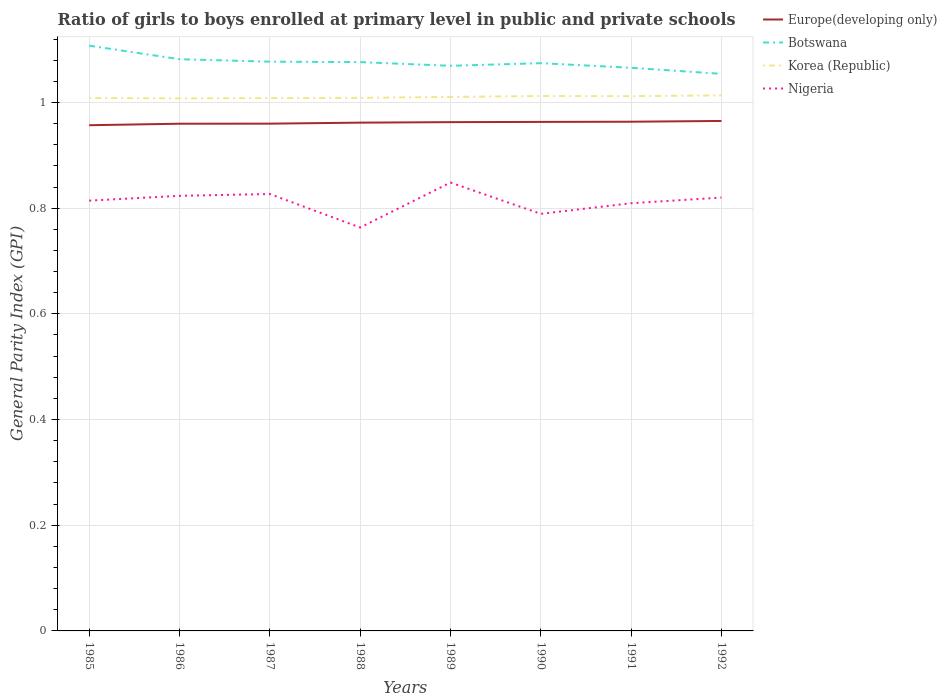How many different coloured lines are there?
Your answer should be very brief. 4. Is the number of lines equal to the number of legend labels?
Give a very brief answer. Yes. Across all years, what is the maximum general parity index in Korea (Republic)?
Ensure brevity in your answer.  1.01. What is the total general parity index in Europe(developing only) in the graph?
Offer a very short reply. -0. What is the difference between the highest and the second highest general parity index in Korea (Republic)?
Make the answer very short. 0.01. What is the difference between the highest and the lowest general parity index in Nigeria?
Give a very brief answer. 5. How many lines are there?
Make the answer very short. 4. Does the graph contain any zero values?
Your answer should be very brief. No. Does the graph contain grids?
Give a very brief answer. Yes. How are the legend labels stacked?
Ensure brevity in your answer.  Vertical. What is the title of the graph?
Your answer should be compact. Ratio of girls to boys enrolled at primary level in public and private schools. What is the label or title of the Y-axis?
Your answer should be very brief. General Parity Index (GPI). What is the General Parity Index (GPI) of Europe(developing only) in 1985?
Your response must be concise. 0.96. What is the General Parity Index (GPI) in Botswana in 1985?
Ensure brevity in your answer.  1.11. What is the General Parity Index (GPI) in Korea (Republic) in 1985?
Your answer should be very brief. 1.01. What is the General Parity Index (GPI) of Nigeria in 1985?
Give a very brief answer. 0.81. What is the General Parity Index (GPI) in Europe(developing only) in 1986?
Offer a terse response. 0.96. What is the General Parity Index (GPI) of Botswana in 1986?
Provide a succinct answer. 1.08. What is the General Parity Index (GPI) of Korea (Republic) in 1986?
Offer a very short reply. 1.01. What is the General Parity Index (GPI) in Nigeria in 1986?
Ensure brevity in your answer.  0.82. What is the General Parity Index (GPI) of Europe(developing only) in 1987?
Provide a short and direct response. 0.96. What is the General Parity Index (GPI) of Botswana in 1987?
Your response must be concise. 1.08. What is the General Parity Index (GPI) of Korea (Republic) in 1987?
Make the answer very short. 1.01. What is the General Parity Index (GPI) in Nigeria in 1987?
Make the answer very short. 0.83. What is the General Parity Index (GPI) in Europe(developing only) in 1988?
Your response must be concise. 0.96. What is the General Parity Index (GPI) in Botswana in 1988?
Provide a short and direct response. 1.08. What is the General Parity Index (GPI) of Korea (Republic) in 1988?
Offer a terse response. 1.01. What is the General Parity Index (GPI) in Nigeria in 1988?
Your answer should be compact. 0.76. What is the General Parity Index (GPI) in Europe(developing only) in 1989?
Offer a terse response. 0.96. What is the General Parity Index (GPI) in Botswana in 1989?
Your answer should be compact. 1.07. What is the General Parity Index (GPI) of Korea (Republic) in 1989?
Provide a succinct answer. 1.01. What is the General Parity Index (GPI) of Nigeria in 1989?
Offer a very short reply. 0.85. What is the General Parity Index (GPI) in Europe(developing only) in 1990?
Provide a short and direct response. 0.96. What is the General Parity Index (GPI) of Botswana in 1990?
Offer a terse response. 1.07. What is the General Parity Index (GPI) of Korea (Republic) in 1990?
Offer a terse response. 1.01. What is the General Parity Index (GPI) in Nigeria in 1990?
Your answer should be very brief. 0.79. What is the General Parity Index (GPI) of Europe(developing only) in 1991?
Your answer should be compact. 0.96. What is the General Parity Index (GPI) of Botswana in 1991?
Your answer should be compact. 1.07. What is the General Parity Index (GPI) of Korea (Republic) in 1991?
Your answer should be very brief. 1.01. What is the General Parity Index (GPI) in Nigeria in 1991?
Keep it short and to the point. 0.81. What is the General Parity Index (GPI) of Europe(developing only) in 1992?
Offer a terse response. 0.97. What is the General Parity Index (GPI) in Botswana in 1992?
Give a very brief answer. 1.05. What is the General Parity Index (GPI) in Korea (Republic) in 1992?
Offer a terse response. 1.01. What is the General Parity Index (GPI) of Nigeria in 1992?
Keep it short and to the point. 0.82. Across all years, what is the maximum General Parity Index (GPI) in Europe(developing only)?
Offer a terse response. 0.97. Across all years, what is the maximum General Parity Index (GPI) in Botswana?
Your answer should be very brief. 1.11. Across all years, what is the maximum General Parity Index (GPI) of Korea (Republic)?
Your answer should be compact. 1.01. Across all years, what is the maximum General Parity Index (GPI) in Nigeria?
Provide a succinct answer. 0.85. Across all years, what is the minimum General Parity Index (GPI) in Europe(developing only)?
Ensure brevity in your answer.  0.96. Across all years, what is the minimum General Parity Index (GPI) in Botswana?
Ensure brevity in your answer.  1.05. Across all years, what is the minimum General Parity Index (GPI) in Korea (Republic)?
Your answer should be very brief. 1.01. Across all years, what is the minimum General Parity Index (GPI) in Nigeria?
Provide a succinct answer. 0.76. What is the total General Parity Index (GPI) of Europe(developing only) in the graph?
Provide a short and direct response. 7.69. What is the total General Parity Index (GPI) in Botswana in the graph?
Your answer should be very brief. 8.61. What is the total General Parity Index (GPI) in Korea (Republic) in the graph?
Your answer should be compact. 8.08. What is the total General Parity Index (GPI) of Nigeria in the graph?
Provide a short and direct response. 6.49. What is the difference between the General Parity Index (GPI) of Europe(developing only) in 1985 and that in 1986?
Keep it short and to the point. -0. What is the difference between the General Parity Index (GPI) in Botswana in 1985 and that in 1986?
Your answer should be very brief. 0.03. What is the difference between the General Parity Index (GPI) of Korea (Republic) in 1985 and that in 1986?
Ensure brevity in your answer.  0. What is the difference between the General Parity Index (GPI) of Nigeria in 1985 and that in 1986?
Your answer should be very brief. -0.01. What is the difference between the General Parity Index (GPI) in Europe(developing only) in 1985 and that in 1987?
Make the answer very short. -0. What is the difference between the General Parity Index (GPI) in Botswana in 1985 and that in 1987?
Provide a short and direct response. 0.03. What is the difference between the General Parity Index (GPI) of Nigeria in 1985 and that in 1987?
Ensure brevity in your answer.  -0.01. What is the difference between the General Parity Index (GPI) of Europe(developing only) in 1985 and that in 1988?
Offer a terse response. -0. What is the difference between the General Parity Index (GPI) of Botswana in 1985 and that in 1988?
Ensure brevity in your answer.  0.03. What is the difference between the General Parity Index (GPI) in Korea (Republic) in 1985 and that in 1988?
Your answer should be very brief. -0. What is the difference between the General Parity Index (GPI) in Nigeria in 1985 and that in 1988?
Your answer should be very brief. 0.05. What is the difference between the General Parity Index (GPI) of Europe(developing only) in 1985 and that in 1989?
Your answer should be very brief. -0.01. What is the difference between the General Parity Index (GPI) in Botswana in 1985 and that in 1989?
Your answer should be compact. 0.04. What is the difference between the General Parity Index (GPI) in Korea (Republic) in 1985 and that in 1989?
Offer a very short reply. -0. What is the difference between the General Parity Index (GPI) of Nigeria in 1985 and that in 1989?
Give a very brief answer. -0.03. What is the difference between the General Parity Index (GPI) in Europe(developing only) in 1985 and that in 1990?
Keep it short and to the point. -0.01. What is the difference between the General Parity Index (GPI) of Botswana in 1985 and that in 1990?
Make the answer very short. 0.03. What is the difference between the General Parity Index (GPI) in Korea (Republic) in 1985 and that in 1990?
Offer a terse response. -0. What is the difference between the General Parity Index (GPI) of Nigeria in 1985 and that in 1990?
Ensure brevity in your answer.  0.03. What is the difference between the General Parity Index (GPI) of Europe(developing only) in 1985 and that in 1991?
Your response must be concise. -0.01. What is the difference between the General Parity Index (GPI) in Botswana in 1985 and that in 1991?
Keep it short and to the point. 0.04. What is the difference between the General Parity Index (GPI) in Korea (Republic) in 1985 and that in 1991?
Provide a succinct answer. -0. What is the difference between the General Parity Index (GPI) of Nigeria in 1985 and that in 1991?
Give a very brief answer. 0. What is the difference between the General Parity Index (GPI) in Europe(developing only) in 1985 and that in 1992?
Provide a succinct answer. -0.01. What is the difference between the General Parity Index (GPI) of Botswana in 1985 and that in 1992?
Offer a terse response. 0.05. What is the difference between the General Parity Index (GPI) of Korea (Republic) in 1985 and that in 1992?
Ensure brevity in your answer.  -0. What is the difference between the General Parity Index (GPI) of Nigeria in 1985 and that in 1992?
Offer a terse response. -0.01. What is the difference between the General Parity Index (GPI) in Europe(developing only) in 1986 and that in 1987?
Your answer should be compact. -0. What is the difference between the General Parity Index (GPI) of Botswana in 1986 and that in 1987?
Your answer should be compact. 0. What is the difference between the General Parity Index (GPI) in Korea (Republic) in 1986 and that in 1987?
Keep it short and to the point. -0. What is the difference between the General Parity Index (GPI) of Nigeria in 1986 and that in 1987?
Offer a terse response. -0. What is the difference between the General Parity Index (GPI) of Europe(developing only) in 1986 and that in 1988?
Provide a succinct answer. -0. What is the difference between the General Parity Index (GPI) of Botswana in 1986 and that in 1988?
Give a very brief answer. 0.01. What is the difference between the General Parity Index (GPI) in Korea (Republic) in 1986 and that in 1988?
Provide a short and direct response. -0. What is the difference between the General Parity Index (GPI) in Nigeria in 1986 and that in 1988?
Your answer should be very brief. 0.06. What is the difference between the General Parity Index (GPI) in Europe(developing only) in 1986 and that in 1989?
Provide a succinct answer. -0. What is the difference between the General Parity Index (GPI) of Botswana in 1986 and that in 1989?
Provide a short and direct response. 0.01. What is the difference between the General Parity Index (GPI) of Korea (Republic) in 1986 and that in 1989?
Offer a terse response. -0. What is the difference between the General Parity Index (GPI) of Nigeria in 1986 and that in 1989?
Your answer should be very brief. -0.03. What is the difference between the General Parity Index (GPI) of Europe(developing only) in 1986 and that in 1990?
Offer a terse response. -0. What is the difference between the General Parity Index (GPI) in Botswana in 1986 and that in 1990?
Your answer should be compact. 0.01. What is the difference between the General Parity Index (GPI) in Korea (Republic) in 1986 and that in 1990?
Offer a very short reply. -0. What is the difference between the General Parity Index (GPI) in Nigeria in 1986 and that in 1990?
Ensure brevity in your answer.  0.03. What is the difference between the General Parity Index (GPI) in Europe(developing only) in 1986 and that in 1991?
Offer a very short reply. -0. What is the difference between the General Parity Index (GPI) in Botswana in 1986 and that in 1991?
Keep it short and to the point. 0.02. What is the difference between the General Parity Index (GPI) in Korea (Republic) in 1986 and that in 1991?
Give a very brief answer. -0. What is the difference between the General Parity Index (GPI) in Nigeria in 1986 and that in 1991?
Keep it short and to the point. 0.01. What is the difference between the General Parity Index (GPI) in Europe(developing only) in 1986 and that in 1992?
Provide a succinct answer. -0.01. What is the difference between the General Parity Index (GPI) of Botswana in 1986 and that in 1992?
Provide a succinct answer. 0.03. What is the difference between the General Parity Index (GPI) in Korea (Republic) in 1986 and that in 1992?
Keep it short and to the point. -0.01. What is the difference between the General Parity Index (GPI) of Nigeria in 1986 and that in 1992?
Ensure brevity in your answer.  0. What is the difference between the General Parity Index (GPI) in Europe(developing only) in 1987 and that in 1988?
Your answer should be compact. -0. What is the difference between the General Parity Index (GPI) of Botswana in 1987 and that in 1988?
Give a very brief answer. 0. What is the difference between the General Parity Index (GPI) in Korea (Republic) in 1987 and that in 1988?
Offer a terse response. -0. What is the difference between the General Parity Index (GPI) in Nigeria in 1987 and that in 1988?
Provide a succinct answer. 0.06. What is the difference between the General Parity Index (GPI) of Europe(developing only) in 1987 and that in 1989?
Your response must be concise. -0. What is the difference between the General Parity Index (GPI) in Botswana in 1987 and that in 1989?
Offer a very short reply. 0.01. What is the difference between the General Parity Index (GPI) in Korea (Republic) in 1987 and that in 1989?
Give a very brief answer. -0. What is the difference between the General Parity Index (GPI) of Nigeria in 1987 and that in 1989?
Your response must be concise. -0.02. What is the difference between the General Parity Index (GPI) of Europe(developing only) in 1987 and that in 1990?
Provide a short and direct response. -0. What is the difference between the General Parity Index (GPI) in Botswana in 1987 and that in 1990?
Provide a succinct answer. 0. What is the difference between the General Parity Index (GPI) of Korea (Republic) in 1987 and that in 1990?
Ensure brevity in your answer.  -0. What is the difference between the General Parity Index (GPI) of Nigeria in 1987 and that in 1990?
Your answer should be very brief. 0.04. What is the difference between the General Parity Index (GPI) in Europe(developing only) in 1987 and that in 1991?
Provide a succinct answer. -0. What is the difference between the General Parity Index (GPI) in Botswana in 1987 and that in 1991?
Keep it short and to the point. 0.01. What is the difference between the General Parity Index (GPI) of Korea (Republic) in 1987 and that in 1991?
Give a very brief answer. -0. What is the difference between the General Parity Index (GPI) in Nigeria in 1987 and that in 1991?
Offer a very short reply. 0.02. What is the difference between the General Parity Index (GPI) of Europe(developing only) in 1987 and that in 1992?
Keep it short and to the point. -0.01. What is the difference between the General Parity Index (GPI) of Botswana in 1987 and that in 1992?
Your answer should be compact. 0.02. What is the difference between the General Parity Index (GPI) of Korea (Republic) in 1987 and that in 1992?
Offer a terse response. -0.01. What is the difference between the General Parity Index (GPI) in Nigeria in 1987 and that in 1992?
Make the answer very short. 0.01. What is the difference between the General Parity Index (GPI) in Europe(developing only) in 1988 and that in 1989?
Make the answer very short. -0. What is the difference between the General Parity Index (GPI) of Botswana in 1988 and that in 1989?
Your response must be concise. 0.01. What is the difference between the General Parity Index (GPI) in Korea (Republic) in 1988 and that in 1989?
Provide a short and direct response. -0. What is the difference between the General Parity Index (GPI) in Nigeria in 1988 and that in 1989?
Make the answer very short. -0.09. What is the difference between the General Parity Index (GPI) of Europe(developing only) in 1988 and that in 1990?
Ensure brevity in your answer.  -0. What is the difference between the General Parity Index (GPI) of Botswana in 1988 and that in 1990?
Make the answer very short. 0. What is the difference between the General Parity Index (GPI) in Korea (Republic) in 1988 and that in 1990?
Offer a very short reply. -0. What is the difference between the General Parity Index (GPI) in Nigeria in 1988 and that in 1990?
Your answer should be very brief. -0.03. What is the difference between the General Parity Index (GPI) of Europe(developing only) in 1988 and that in 1991?
Your response must be concise. -0. What is the difference between the General Parity Index (GPI) in Botswana in 1988 and that in 1991?
Give a very brief answer. 0.01. What is the difference between the General Parity Index (GPI) of Korea (Republic) in 1988 and that in 1991?
Provide a succinct answer. -0. What is the difference between the General Parity Index (GPI) of Nigeria in 1988 and that in 1991?
Offer a terse response. -0.05. What is the difference between the General Parity Index (GPI) in Europe(developing only) in 1988 and that in 1992?
Your response must be concise. -0. What is the difference between the General Parity Index (GPI) in Botswana in 1988 and that in 1992?
Provide a succinct answer. 0.02. What is the difference between the General Parity Index (GPI) in Korea (Republic) in 1988 and that in 1992?
Offer a terse response. -0. What is the difference between the General Parity Index (GPI) of Nigeria in 1988 and that in 1992?
Give a very brief answer. -0.06. What is the difference between the General Parity Index (GPI) in Europe(developing only) in 1989 and that in 1990?
Ensure brevity in your answer.  -0. What is the difference between the General Parity Index (GPI) of Botswana in 1989 and that in 1990?
Your answer should be compact. -0.01. What is the difference between the General Parity Index (GPI) in Korea (Republic) in 1989 and that in 1990?
Your answer should be very brief. -0. What is the difference between the General Parity Index (GPI) of Nigeria in 1989 and that in 1990?
Your response must be concise. 0.06. What is the difference between the General Parity Index (GPI) in Europe(developing only) in 1989 and that in 1991?
Offer a terse response. -0. What is the difference between the General Parity Index (GPI) in Botswana in 1989 and that in 1991?
Your answer should be compact. 0. What is the difference between the General Parity Index (GPI) in Korea (Republic) in 1989 and that in 1991?
Your answer should be compact. -0. What is the difference between the General Parity Index (GPI) in Nigeria in 1989 and that in 1991?
Give a very brief answer. 0.04. What is the difference between the General Parity Index (GPI) in Europe(developing only) in 1989 and that in 1992?
Your response must be concise. -0. What is the difference between the General Parity Index (GPI) in Botswana in 1989 and that in 1992?
Offer a terse response. 0.02. What is the difference between the General Parity Index (GPI) of Korea (Republic) in 1989 and that in 1992?
Ensure brevity in your answer.  -0. What is the difference between the General Parity Index (GPI) in Nigeria in 1989 and that in 1992?
Your answer should be compact. 0.03. What is the difference between the General Parity Index (GPI) in Europe(developing only) in 1990 and that in 1991?
Offer a very short reply. -0. What is the difference between the General Parity Index (GPI) in Botswana in 1990 and that in 1991?
Ensure brevity in your answer.  0.01. What is the difference between the General Parity Index (GPI) of Korea (Republic) in 1990 and that in 1991?
Give a very brief answer. 0. What is the difference between the General Parity Index (GPI) of Nigeria in 1990 and that in 1991?
Your response must be concise. -0.02. What is the difference between the General Parity Index (GPI) of Europe(developing only) in 1990 and that in 1992?
Your response must be concise. -0. What is the difference between the General Parity Index (GPI) in Botswana in 1990 and that in 1992?
Your response must be concise. 0.02. What is the difference between the General Parity Index (GPI) of Korea (Republic) in 1990 and that in 1992?
Your answer should be very brief. -0. What is the difference between the General Parity Index (GPI) of Nigeria in 1990 and that in 1992?
Ensure brevity in your answer.  -0.03. What is the difference between the General Parity Index (GPI) of Europe(developing only) in 1991 and that in 1992?
Offer a terse response. -0. What is the difference between the General Parity Index (GPI) of Botswana in 1991 and that in 1992?
Provide a short and direct response. 0.01. What is the difference between the General Parity Index (GPI) of Korea (Republic) in 1991 and that in 1992?
Offer a very short reply. -0. What is the difference between the General Parity Index (GPI) in Nigeria in 1991 and that in 1992?
Your answer should be compact. -0.01. What is the difference between the General Parity Index (GPI) of Europe(developing only) in 1985 and the General Parity Index (GPI) of Botswana in 1986?
Make the answer very short. -0.12. What is the difference between the General Parity Index (GPI) in Europe(developing only) in 1985 and the General Parity Index (GPI) in Korea (Republic) in 1986?
Offer a very short reply. -0.05. What is the difference between the General Parity Index (GPI) of Europe(developing only) in 1985 and the General Parity Index (GPI) of Nigeria in 1986?
Your answer should be very brief. 0.13. What is the difference between the General Parity Index (GPI) of Botswana in 1985 and the General Parity Index (GPI) of Korea (Republic) in 1986?
Ensure brevity in your answer.  0.1. What is the difference between the General Parity Index (GPI) of Botswana in 1985 and the General Parity Index (GPI) of Nigeria in 1986?
Make the answer very short. 0.28. What is the difference between the General Parity Index (GPI) in Korea (Republic) in 1985 and the General Parity Index (GPI) in Nigeria in 1986?
Provide a succinct answer. 0.19. What is the difference between the General Parity Index (GPI) of Europe(developing only) in 1985 and the General Parity Index (GPI) of Botswana in 1987?
Your answer should be compact. -0.12. What is the difference between the General Parity Index (GPI) of Europe(developing only) in 1985 and the General Parity Index (GPI) of Korea (Republic) in 1987?
Give a very brief answer. -0.05. What is the difference between the General Parity Index (GPI) of Europe(developing only) in 1985 and the General Parity Index (GPI) of Nigeria in 1987?
Offer a terse response. 0.13. What is the difference between the General Parity Index (GPI) in Botswana in 1985 and the General Parity Index (GPI) in Korea (Republic) in 1987?
Keep it short and to the point. 0.1. What is the difference between the General Parity Index (GPI) in Botswana in 1985 and the General Parity Index (GPI) in Nigeria in 1987?
Your answer should be very brief. 0.28. What is the difference between the General Parity Index (GPI) of Korea (Republic) in 1985 and the General Parity Index (GPI) of Nigeria in 1987?
Offer a terse response. 0.18. What is the difference between the General Parity Index (GPI) of Europe(developing only) in 1985 and the General Parity Index (GPI) of Botswana in 1988?
Your answer should be very brief. -0.12. What is the difference between the General Parity Index (GPI) of Europe(developing only) in 1985 and the General Parity Index (GPI) of Korea (Republic) in 1988?
Offer a terse response. -0.05. What is the difference between the General Parity Index (GPI) in Europe(developing only) in 1985 and the General Parity Index (GPI) in Nigeria in 1988?
Offer a terse response. 0.19. What is the difference between the General Parity Index (GPI) of Botswana in 1985 and the General Parity Index (GPI) of Korea (Republic) in 1988?
Your response must be concise. 0.1. What is the difference between the General Parity Index (GPI) of Botswana in 1985 and the General Parity Index (GPI) of Nigeria in 1988?
Ensure brevity in your answer.  0.34. What is the difference between the General Parity Index (GPI) in Korea (Republic) in 1985 and the General Parity Index (GPI) in Nigeria in 1988?
Make the answer very short. 0.25. What is the difference between the General Parity Index (GPI) of Europe(developing only) in 1985 and the General Parity Index (GPI) of Botswana in 1989?
Offer a very short reply. -0.11. What is the difference between the General Parity Index (GPI) in Europe(developing only) in 1985 and the General Parity Index (GPI) in Korea (Republic) in 1989?
Offer a terse response. -0.05. What is the difference between the General Parity Index (GPI) of Europe(developing only) in 1985 and the General Parity Index (GPI) of Nigeria in 1989?
Ensure brevity in your answer.  0.11. What is the difference between the General Parity Index (GPI) of Botswana in 1985 and the General Parity Index (GPI) of Korea (Republic) in 1989?
Your response must be concise. 0.1. What is the difference between the General Parity Index (GPI) of Botswana in 1985 and the General Parity Index (GPI) of Nigeria in 1989?
Your answer should be very brief. 0.26. What is the difference between the General Parity Index (GPI) in Korea (Republic) in 1985 and the General Parity Index (GPI) in Nigeria in 1989?
Ensure brevity in your answer.  0.16. What is the difference between the General Parity Index (GPI) of Europe(developing only) in 1985 and the General Parity Index (GPI) of Botswana in 1990?
Make the answer very short. -0.12. What is the difference between the General Parity Index (GPI) of Europe(developing only) in 1985 and the General Parity Index (GPI) of Korea (Republic) in 1990?
Provide a succinct answer. -0.06. What is the difference between the General Parity Index (GPI) in Europe(developing only) in 1985 and the General Parity Index (GPI) in Nigeria in 1990?
Provide a succinct answer. 0.17. What is the difference between the General Parity Index (GPI) of Botswana in 1985 and the General Parity Index (GPI) of Korea (Republic) in 1990?
Make the answer very short. 0.1. What is the difference between the General Parity Index (GPI) in Botswana in 1985 and the General Parity Index (GPI) in Nigeria in 1990?
Ensure brevity in your answer.  0.32. What is the difference between the General Parity Index (GPI) in Korea (Republic) in 1985 and the General Parity Index (GPI) in Nigeria in 1990?
Your response must be concise. 0.22. What is the difference between the General Parity Index (GPI) in Europe(developing only) in 1985 and the General Parity Index (GPI) in Botswana in 1991?
Provide a succinct answer. -0.11. What is the difference between the General Parity Index (GPI) of Europe(developing only) in 1985 and the General Parity Index (GPI) of Korea (Republic) in 1991?
Keep it short and to the point. -0.06. What is the difference between the General Parity Index (GPI) of Europe(developing only) in 1985 and the General Parity Index (GPI) of Nigeria in 1991?
Keep it short and to the point. 0.15. What is the difference between the General Parity Index (GPI) of Botswana in 1985 and the General Parity Index (GPI) of Korea (Republic) in 1991?
Your response must be concise. 0.1. What is the difference between the General Parity Index (GPI) in Botswana in 1985 and the General Parity Index (GPI) in Nigeria in 1991?
Keep it short and to the point. 0.3. What is the difference between the General Parity Index (GPI) in Korea (Republic) in 1985 and the General Parity Index (GPI) in Nigeria in 1991?
Your response must be concise. 0.2. What is the difference between the General Parity Index (GPI) in Europe(developing only) in 1985 and the General Parity Index (GPI) in Botswana in 1992?
Make the answer very short. -0.1. What is the difference between the General Parity Index (GPI) of Europe(developing only) in 1985 and the General Parity Index (GPI) of Korea (Republic) in 1992?
Ensure brevity in your answer.  -0.06. What is the difference between the General Parity Index (GPI) of Europe(developing only) in 1985 and the General Parity Index (GPI) of Nigeria in 1992?
Your response must be concise. 0.14. What is the difference between the General Parity Index (GPI) of Botswana in 1985 and the General Parity Index (GPI) of Korea (Republic) in 1992?
Offer a very short reply. 0.09. What is the difference between the General Parity Index (GPI) of Botswana in 1985 and the General Parity Index (GPI) of Nigeria in 1992?
Keep it short and to the point. 0.29. What is the difference between the General Parity Index (GPI) of Korea (Republic) in 1985 and the General Parity Index (GPI) of Nigeria in 1992?
Make the answer very short. 0.19. What is the difference between the General Parity Index (GPI) of Europe(developing only) in 1986 and the General Parity Index (GPI) of Botswana in 1987?
Provide a succinct answer. -0.12. What is the difference between the General Parity Index (GPI) in Europe(developing only) in 1986 and the General Parity Index (GPI) in Korea (Republic) in 1987?
Make the answer very short. -0.05. What is the difference between the General Parity Index (GPI) of Europe(developing only) in 1986 and the General Parity Index (GPI) of Nigeria in 1987?
Provide a short and direct response. 0.13. What is the difference between the General Parity Index (GPI) of Botswana in 1986 and the General Parity Index (GPI) of Korea (Republic) in 1987?
Provide a short and direct response. 0.07. What is the difference between the General Parity Index (GPI) of Botswana in 1986 and the General Parity Index (GPI) of Nigeria in 1987?
Your response must be concise. 0.26. What is the difference between the General Parity Index (GPI) of Korea (Republic) in 1986 and the General Parity Index (GPI) of Nigeria in 1987?
Provide a succinct answer. 0.18. What is the difference between the General Parity Index (GPI) of Europe(developing only) in 1986 and the General Parity Index (GPI) of Botswana in 1988?
Ensure brevity in your answer.  -0.12. What is the difference between the General Parity Index (GPI) of Europe(developing only) in 1986 and the General Parity Index (GPI) of Korea (Republic) in 1988?
Make the answer very short. -0.05. What is the difference between the General Parity Index (GPI) of Europe(developing only) in 1986 and the General Parity Index (GPI) of Nigeria in 1988?
Ensure brevity in your answer.  0.2. What is the difference between the General Parity Index (GPI) in Botswana in 1986 and the General Parity Index (GPI) in Korea (Republic) in 1988?
Offer a very short reply. 0.07. What is the difference between the General Parity Index (GPI) in Botswana in 1986 and the General Parity Index (GPI) in Nigeria in 1988?
Provide a short and direct response. 0.32. What is the difference between the General Parity Index (GPI) of Korea (Republic) in 1986 and the General Parity Index (GPI) of Nigeria in 1988?
Keep it short and to the point. 0.24. What is the difference between the General Parity Index (GPI) of Europe(developing only) in 1986 and the General Parity Index (GPI) of Botswana in 1989?
Your response must be concise. -0.11. What is the difference between the General Parity Index (GPI) in Europe(developing only) in 1986 and the General Parity Index (GPI) in Korea (Republic) in 1989?
Offer a terse response. -0.05. What is the difference between the General Parity Index (GPI) of Europe(developing only) in 1986 and the General Parity Index (GPI) of Nigeria in 1989?
Offer a very short reply. 0.11. What is the difference between the General Parity Index (GPI) in Botswana in 1986 and the General Parity Index (GPI) in Korea (Republic) in 1989?
Provide a succinct answer. 0.07. What is the difference between the General Parity Index (GPI) in Botswana in 1986 and the General Parity Index (GPI) in Nigeria in 1989?
Provide a short and direct response. 0.23. What is the difference between the General Parity Index (GPI) of Korea (Republic) in 1986 and the General Parity Index (GPI) of Nigeria in 1989?
Ensure brevity in your answer.  0.16. What is the difference between the General Parity Index (GPI) of Europe(developing only) in 1986 and the General Parity Index (GPI) of Botswana in 1990?
Your response must be concise. -0.11. What is the difference between the General Parity Index (GPI) of Europe(developing only) in 1986 and the General Parity Index (GPI) of Korea (Republic) in 1990?
Ensure brevity in your answer.  -0.05. What is the difference between the General Parity Index (GPI) in Europe(developing only) in 1986 and the General Parity Index (GPI) in Nigeria in 1990?
Provide a succinct answer. 0.17. What is the difference between the General Parity Index (GPI) in Botswana in 1986 and the General Parity Index (GPI) in Korea (Republic) in 1990?
Your answer should be compact. 0.07. What is the difference between the General Parity Index (GPI) of Botswana in 1986 and the General Parity Index (GPI) of Nigeria in 1990?
Your answer should be very brief. 0.29. What is the difference between the General Parity Index (GPI) in Korea (Republic) in 1986 and the General Parity Index (GPI) in Nigeria in 1990?
Your answer should be very brief. 0.22. What is the difference between the General Parity Index (GPI) of Europe(developing only) in 1986 and the General Parity Index (GPI) of Botswana in 1991?
Ensure brevity in your answer.  -0.11. What is the difference between the General Parity Index (GPI) in Europe(developing only) in 1986 and the General Parity Index (GPI) in Korea (Republic) in 1991?
Make the answer very short. -0.05. What is the difference between the General Parity Index (GPI) of Europe(developing only) in 1986 and the General Parity Index (GPI) of Nigeria in 1991?
Give a very brief answer. 0.15. What is the difference between the General Parity Index (GPI) of Botswana in 1986 and the General Parity Index (GPI) of Korea (Republic) in 1991?
Offer a very short reply. 0.07. What is the difference between the General Parity Index (GPI) in Botswana in 1986 and the General Parity Index (GPI) in Nigeria in 1991?
Keep it short and to the point. 0.27. What is the difference between the General Parity Index (GPI) in Korea (Republic) in 1986 and the General Parity Index (GPI) in Nigeria in 1991?
Your response must be concise. 0.2. What is the difference between the General Parity Index (GPI) of Europe(developing only) in 1986 and the General Parity Index (GPI) of Botswana in 1992?
Offer a terse response. -0.09. What is the difference between the General Parity Index (GPI) of Europe(developing only) in 1986 and the General Parity Index (GPI) of Korea (Republic) in 1992?
Offer a very short reply. -0.05. What is the difference between the General Parity Index (GPI) of Europe(developing only) in 1986 and the General Parity Index (GPI) of Nigeria in 1992?
Provide a succinct answer. 0.14. What is the difference between the General Parity Index (GPI) of Botswana in 1986 and the General Parity Index (GPI) of Korea (Republic) in 1992?
Give a very brief answer. 0.07. What is the difference between the General Parity Index (GPI) of Botswana in 1986 and the General Parity Index (GPI) of Nigeria in 1992?
Offer a very short reply. 0.26. What is the difference between the General Parity Index (GPI) in Korea (Republic) in 1986 and the General Parity Index (GPI) in Nigeria in 1992?
Your answer should be very brief. 0.19. What is the difference between the General Parity Index (GPI) of Europe(developing only) in 1987 and the General Parity Index (GPI) of Botswana in 1988?
Your answer should be compact. -0.12. What is the difference between the General Parity Index (GPI) in Europe(developing only) in 1987 and the General Parity Index (GPI) in Korea (Republic) in 1988?
Your response must be concise. -0.05. What is the difference between the General Parity Index (GPI) in Europe(developing only) in 1987 and the General Parity Index (GPI) in Nigeria in 1988?
Offer a very short reply. 0.2. What is the difference between the General Parity Index (GPI) of Botswana in 1987 and the General Parity Index (GPI) of Korea (Republic) in 1988?
Ensure brevity in your answer.  0.07. What is the difference between the General Parity Index (GPI) in Botswana in 1987 and the General Parity Index (GPI) in Nigeria in 1988?
Provide a short and direct response. 0.31. What is the difference between the General Parity Index (GPI) of Korea (Republic) in 1987 and the General Parity Index (GPI) of Nigeria in 1988?
Provide a succinct answer. 0.24. What is the difference between the General Parity Index (GPI) in Europe(developing only) in 1987 and the General Parity Index (GPI) in Botswana in 1989?
Provide a succinct answer. -0.11. What is the difference between the General Parity Index (GPI) in Europe(developing only) in 1987 and the General Parity Index (GPI) in Korea (Republic) in 1989?
Offer a very short reply. -0.05. What is the difference between the General Parity Index (GPI) in Europe(developing only) in 1987 and the General Parity Index (GPI) in Nigeria in 1989?
Ensure brevity in your answer.  0.11. What is the difference between the General Parity Index (GPI) in Botswana in 1987 and the General Parity Index (GPI) in Korea (Republic) in 1989?
Your answer should be compact. 0.07. What is the difference between the General Parity Index (GPI) of Botswana in 1987 and the General Parity Index (GPI) of Nigeria in 1989?
Your answer should be very brief. 0.23. What is the difference between the General Parity Index (GPI) of Korea (Republic) in 1987 and the General Parity Index (GPI) of Nigeria in 1989?
Make the answer very short. 0.16. What is the difference between the General Parity Index (GPI) in Europe(developing only) in 1987 and the General Parity Index (GPI) in Botswana in 1990?
Make the answer very short. -0.11. What is the difference between the General Parity Index (GPI) of Europe(developing only) in 1987 and the General Parity Index (GPI) of Korea (Republic) in 1990?
Give a very brief answer. -0.05. What is the difference between the General Parity Index (GPI) of Europe(developing only) in 1987 and the General Parity Index (GPI) of Nigeria in 1990?
Keep it short and to the point. 0.17. What is the difference between the General Parity Index (GPI) in Botswana in 1987 and the General Parity Index (GPI) in Korea (Republic) in 1990?
Keep it short and to the point. 0.07. What is the difference between the General Parity Index (GPI) of Botswana in 1987 and the General Parity Index (GPI) of Nigeria in 1990?
Keep it short and to the point. 0.29. What is the difference between the General Parity Index (GPI) in Korea (Republic) in 1987 and the General Parity Index (GPI) in Nigeria in 1990?
Your answer should be very brief. 0.22. What is the difference between the General Parity Index (GPI) in Europe(developing only) in 1987 and the General Parity Index (GPI) in Botswana in 1991?
Your answer should be very brief. -0.11. What is the difference between the General Parity Index (GPI) of Europe(developing only) in 1987 and the General Parity Index (GPI) of Korea (Republic) in 1991?
Ensure brevity in your answer.  -0.05. What is the difference between the General Parity Index (GPI) of Europe(developing only) in 1987 and the General Parity Index (GPI) of Nigeria in 1991?
Give a very brief answer. 0.15. What is the difference between the General Parity Index (GPI) of Botswana in 1987 and the General Parity Index (GPI) of Korea (Republic) in 1991?
Ensure brevity in your answer.  0.07. What is the difference between the General Parity Index (GPI) in Botswana in 1987 and the General Parity Index (GPI) in Nigeria in 1991?
Make the answer very short. 0.27. What is the difference between the General Parity Index (GPI) in Korea (Republic) in 1987 and the General Parity Index (GPI) in Nigeria in 1991?
Give a very brief answer. 0.2. What is the difference between the General Parity Index (GPI) of Europe(developing only) in 1987 and the General Parity Index (GPI) of Botswana in 1992?
Your answer should be compact. -0.09. What is the difference between the General Parity Index (GPI) of Europe(developing only) in 1987 and the General Parity Index (GPI) of Korea (Republic) in 1992?
Provide a succinct answer. -0.05. What is the difference between the General Parity Index (GPI) in Europe(developing only) in 1987 and the General Parity Index (GPI) in Nigeria in 1992?
Offer a very short reply. 0.14. What is the difference between the General Parity Index (GPI) in Botswana in 1987 and the General Parity Index (GPI) in Korea (Republic) in 1992?
Keep it short and to the point. 0.06. What is the difference between the General Parity Index (GPI) in Botswana in 1987 and the General Parity Index (GPI) in Nigeria in 1992?
Make the answer very short. 0.26. What is the difference between the General Parity Index (GPI) in Korea (Republic) in 1987 and the General Parity Index (GPI) in Nigeria in 1992?
Keep it short and to the point. 0.19. What is the difference between the General Parity Index (GPI) of Europe(developing only) in 1988 and the General Parity Index (GPI) of Botswana in 1989?
Offer a very short reply. -0.11. What is the difference between the General Parity Index (GPI) of Europe(developing only) in 1988 and the General Parity Index (GPI) of Korea (Republic) in 1989?
Offer a terse response. -0.05. What is the difference between the General Parity Index (GPI) of Europe(developing only) in 1988 and the General Parity Index (GPI) of Nigeria in 1989?
Your answer should be compact. 0.11. What is the difference between the General Parity Index (GPI) of Botswana in 1988 and the General Parity Index (GPI) of Korea (Republic) in 1989?
Your response must be concise. 0.07. What is the difference between the General Parity Index (GPI) of Botswana in 1988 and the General Parity Index (GPI) of Nigeria in 1989?
Ensure brevity in your answer.  0.23. What is the difference between the General Parity Index (GPI) of Korea (Republic) in 1988 and the General Parity Index (GPI) of Nigeria in 1989?
Give a very brief answer. 0.16. What is the difference between the General Parity Index (GPI) of Europe(developing only) in 1988 and the General Parity Index (GPI) of Botswana in 1990?
Ensure brevity in your answer.  -0.11. What is the difference between the General Parity Index (GPI) in Europe(developing only) in 1988 and the General Parity Index (GPI) in Korea (Republic) in 1990?
Your response must be concise. -0.05. What is the difference between the General Parity Index (GPI) in Europe(developing only) in 1988 and the General Parity Index (GPI) in Nigeria in 1990?
Give a very brief answer. 0.17. What is the difference between the General Parity Index (GPI) in Botswana in 1988 and the General Parity Index (GPI) in Korea (Republic) in 1990?
Your response must be concise. 0.06. What is the difference between the General Parity Index (GPI) of Botswana in 1988 and the General Parity Index (GPI) of Nigeria in 1990?
Make the answer very short. 0.29. What is the difference between the General Parity Index (GPI) in Korea (Republic) in 1988 and the General Parity Index (GPI) in Nigeria in 1990?
Provide a short and direct response. 0.22. What is the difference between the General Parity Index (GPI) in Europe(developing only) in 1988 and the General Parity Index (GPI) in Botswana in 1991?
Offer a very short reply. -0.1. What is the difference between the General Parity Index (GPI) in Europe(developing only) in 1988 and the General Parity Index (GPI) in Korea (Republic) in 1991?
Your response must be concise. -0.05. What is the difference between the General Parity Index (GPI) in Europe(developing only) in 1988 and the General Parity Index (GPI) in Nigeria in 1991?
Give a very brief answer. 0.15. What is the difference between the General Parity Index (GPI) of Botswana in 1988 and the General Parity Index (GPI) of Korea (Republic) in 1991?
Provide a succinct answer. 0.06. What is the difference between the General Parity Index (GPI) of Botswana in 1988 and the General Parity Index (GPI) of Nigeria in 1991?
Make the answer very short. 0.27. What is the difference between the General Parity Index (GPI) of Korea (Republic) in 1988 and the General Parity Index (GPI) of Nigeria in 1991?
Offer a very short reply. 0.2. What is the difference between the General Parity Index (GPI) of Europe(developing only) in 1988 and the General Parity Index (GPI) of Botswana in 1992?
Make the answer very short. -0.09. What is the difference between the General Parity Index (GPI) in Europe(developing only) in 1988 and the General Parity Index (GPI) in Korea (Republic) in 1992?
Provide a succinct answer. -0.05. What is the difference between the General Parity Index (GPI) in Europe(developing only) in 1988 and the General Parity Index (GPI) in Nigeria in 1992?
Give a very brief answer. 0.14. What is the difference between the General Parity Index (GPI) in Botswana in 1988 and the General Parity Index (GPI) in Korea (Republic) in 1992?
Make the answer very short. 0.06. What is the difference between the General Parity Index (GPI) in Botswana in 1988 and the General Parity Index (GPI) in Nigeria in 1992?
Offer a very short reply. 0.26. What is the difference between the General Parity Index (GPI) of Korea (Republic) in 1988 and the General Parity Index (GPI) of Nigeria in 1992?
Your answer should be compact. 0.19. What is the difference between the General Parity Index (GPI) in Europe(developing only) in 1989 and the General Parity Index (GPI) in Botswana in 1990?
Offer a terse response. -0.11. What is the difference between the General Parity Index (GPI) in Europe(developing only) in 1989 and the General Parity Index (GPI) in Korea (Republic) in 1990?
Make the answer very short. -0.05. What is the difference between the General Parity Index (GPI) in Europe(developing only) in 1989 and the General Parity Index (GPI) in Nigeria in 1990?
Offer a terse response. 0.17. What is the difference between the General Parity Index (GPI) of Botswana in 1989 and the General Parity Index (GPI) of Korea (Republic) in 1990?
Offer a very short reply. 0.06. What is the difference between the General Parity Index (GPI) of Botswana in 1989 and the General Parity Index (GPI) of Nigeria in 1990?
Provide a succinct answer. 0.28. What is the difference between the General Parity Index (GPI) in Korea (Republic) in 1989 and the General Parity Index (GPI) in Nigeria in 1990?
Offer a very short reply. 0.22. What is the difference between the General Parity Index (GPI) in Europe(developing only) in 1989 and the General Parity Index (GPI) in Botswana in 1991?
Your response must be concise. -0.1. What is the difference between the General Parity Index (GPI) of Europe(developing only) in 1989 and the General Parity Index (GPI) of Korea (Republic) in 1991?
Your answer should be compact. -0.05. What is the difference between the General Parity Index (GPI) of Europe(developing only) in 1989 and the General Parity Index (GPI) of Nigeria in 1991?
Give a very brief answer. 0.15. What is the difference between the General Parity Index (GPI) in Botswana in 1989 and the General Parity Index (GPI) in Korea (Republic) in 1991?
Your response must be concise. 0.06. What is the difference between the General Parity Index (GPI) of Botswana in 1989 and the General Parity Index (GPI) of Nigeria in 1991?
Provide a short and direct response. 0.26. What is the difference between the General Parity Index (GPI) in Korea (Republic) in 1989 and the General Parity Index (GPI) in Nigeria in 1991?
Ensure brevity in your answer.  0.2. What is the difference between the General Parity Index (GPI) in Europe(developing only) in 1989 and the General Parity Index (GPI) in Botswana in 1992?
Offer a very short reply. -0.09. What is the difference between the General Parity Index (GPI) of Europe(developing only) in 1989 and the General Parity Index (GPI) of Korea (Republic) in 1992?
Keep it short and to the point. -0.05. What is the difference between the General Parity Index (GPI) in Europe(developing only) in 1989 and the General Parity Index (GPI) in Nigeria in 1992?
Your answer should be compact. 0.14. What is the difference between the General Parity Index (GPI) in Botswana in 1989 and the General Parity Index (GPI) in Korea (Republic) in 1992?
Provide a succinct answer. 0.06. What is the difference between the General Parity Index (GPI) of Botswana in 1989 and the General Parity Index (GPI) of Nigeria in 1992?
Give a very brief answer. 0.25. What is the difference between the General Parity Index (GPI) of Korea (Republic) in 1989 and the General Parity Index (GPI) of Nigeria in 1992?
Offer a very short reply. 0.19. What is the difference between the General Parity Index (GPI) of Europe(developing only) in 1990 and the General Parity Index (GPI) of Botswana in 1991?
Provide a short and direct response. -0.1. What is the difference between the General Parity Index (GPI) of Europe(developing only) in 1990 and the General Parity Index (GPI) of Korea (Republic) in 1991?
Make the answer very short. -0.05. What is the difference between the General Parity Index (GPI) in Europe(developing only) in 1990 and the General Parity Index (GPI) in Nigeria in 1991?
Your answer should be compact. 0.15. What is the difference between the General Parity Index (GPI) in Botswana in 1990 and the General Parity Index (GPI) in Korea (Republic) in 1991?
Your response must be concise. 0.06. What is the difference between the General Parity Index (GPI) in Botswana in 1990 and the General Parity Index (GPI) in Nigeria in 1991?
Your response must be concise. 0.27. What is the difference between the General Parity Index (GPI) of Korea (Republic) in 1990 and the General Parity Index (GPI) of Nigeria in 1991?
Provide a short and direct response. 0.2. What is the difference between the General Parity Index (GPI) in Europe(developing only) in 1990 and the General Parity Index (GPI) in Botswana in 1992?
Make the answer very short. -0.09. What is the difference between the General Parity Index (GPI) of Europe(developing only) in 1990 and the General Parity Index (GPI) of Korea (Republic) in 1992?
Provide a succinct answer. -0.05. What is the difference between the General Parity Index (GPI) in Europe(developing only) in 1990 and the General Parity Index (GPI) in Nigeria in 1992?
Offer a terse response. 0.14. What is the difference between the General Parity Index (GPI) in Botswana in 1990 and the General Parity Index (GPI) in Korea (Republic) in 1992?
Your answer should be very brief. 0.06. What is the difference between the General Parity Index (GPI) of Botswana in 1990 and the General Parity Index (GPI) of Nigeria in 1992?
Your answer should be compact. 0.25. What is the difference between the General Parity Index (GPI) in Korea (Republic) in 1990 and the General Parity Index (GPI) in Nigeria in 1992?
Offer a very short reply. 0.19. What is the difference between the General Parity Index (GPI) in Europe(developing only) in 1991 and the General Parity Index (GPI) in Botswana in 1992?
Give a very brief answer. -0.09. What is the difference between the General Parity Index (GPI) in Europe(developing only) in 1991 and the General Parity Index (GPI) in Korea (Republic) in 1992?
Make the answer very short. -0.05. What is the difference between the General Parity Index (GPI) in Europe(developing only) in 1991 and the General Parity Index (GPI) in Nigeria in 1992?
Ensure brevity in your answer.  0.14. What is the difference between the General Parity Index (GPI) in Botswana in 1991 and the General Parity Index (GPI) in Korea (Republic) in 1992?
Your answer should be compact. 0.05. What is the difference between the General Parity Index (GPI) in Botswana in 1991 and the General Parity Index (GPI) in Nigeria in 1992?
Your answer should be compact. 0.25. What is the difference between the General Parity Index (GPI) of Korea (Republic) in 1991 and the General Parity Index (GPI) of Nigeria in 1992?
Your response must be concise. 0.19. What is the average General Parity Index (GPI) in Europe(developing only) per year?
Offer a very short reply. 0.96. What is the average General Parity Index (GPI) in Botswana per year?
Give a very brief answer. 1.08. What is the average General Parity Index (GPI) of Korea (Republic) per year?
Offer a terse response. 1.01. What is the average General Parity Index (GPI) of Nigeria per year?
Offer a terse response. 0.81. In the year 1985, what is the difference between the General Parity Index (GPI) in Europe(developing only) and General Parity Index (GPI) in Botswana?
Provide a succinct answer. -0.15. In the year 1985, what is the difference between the General Parity Index (GPI) of Europe(developing only) and General Parity Index (GPI) of Korea (Republic)?
Keep it short and to the point. -0.05. In the year 1985, what is the difference between the General Parity Index (GPI) in Europe(developing only) and General Parity Index (GPI) in Nigeria?
Make the answer very short. 0.14. In the year 1985, what is the difference between the General Parity Index (GPI) of Botswana and General Parity Index (GPI) of Korea (Republic)?
Provide a short and direct response. 0.1. In the year 1985, what is the difference between the General Parity Index (GPI) of Botswana and General Parity Index (GPI) of Nigeria?
Offer a terse response. 0.29. In the year 1985, what is the difference between the General Parity Index (GPI) in Korea (Republic) and General Parity Index (GPI) in Nigeria?
Give a very brief answer. 0.19. In the year 1986, what is the difference between the General Parity Index (GPI) of Europe(developing only) and General Parity Index (GPI) of Botswana?
Offer a very short reply. -0.12. In the year 1986, what is the difference between the General Parity Index (GPI) in Europe(developing only) and General Parity Index (GPI) in Korea (Republic)?
Ensure brevity in your answer.  -0.05. In the year 1986, what is the difference between the General Parity Index (GPI) in Europe(developing only) and General Parity Index (GPI) in Nigeria?
Ensure brevity in your answer.  0.14. In the year 1986, what is the difference between the General Parity Index (GPI) of Botswana and General Parity Index (GPI) of Korea (Republic)?
Provide a succinct answer. 0.07. In the year 1986, what is the difference between the General Parity Index (GPI) of Botswana and General Parity Index (GPI) of Nigeria?
Ensure brevity in your answer.  0.26. In the year 1986, what is the difference between the General Parity Index (GPI) in Korea (Republic) and General Parity Index (GPI) in Nigeria?
Provide a succinct answer. 0.18. In the year 1987, what is the difference between the General Parity Index (GPI) in Europe(developing only) and General Parity Index (GPI) in Botswana?
Your answer should be very brief. -0.12. In the year 1987, what is the difference between the General Parity Index (GPI) of Europe(developing only) and General Parity Index (GPI) of Korea (Republic)?
Offer a terse response. -0.05. In the year 1987, what is the difference between the General Parity Index (GPI) in Europe(developing only) and General Parity Index (GPI) in Nigeria?
Ensure brevity in your answer.  0.13. In the year 1987, what is the difference between the General Parity Index (GPI) in Botswana and General Parity Index (GPI) in Korea (Republic)?
Offer a terse response. 0.07. In the year 1987, what is the difference between the General Parity Index (GPI) in Botswana and General Parity Index (GPI) in Nigeria?
Keep it short and to the point. 0.25. In the year 1987, what is the difference between the General Parity Index (GPI) of Korea (Republic) and General Parity Index (GPI) of Nigeria?
Ensure brevity in your answer.  0.18. In the year 1988, what is the difference between the General Parity Index (GPI) in Europe(developing only) and General Parity Index (GPI) in Botswana?
Your answer should be compact. -0.11. In the year 1988, what is the difference between the General Parity Index (GPI) of Europe(developing only) and General Parity Index (GPI) of Korea (Republic)?
Give a very brief answer. -0.05. In the year 1988, what is the difference between the General Parity Index (GPI) of Europe(developing only) and General Parity Index (GPI) of Nigeria?
Offer a very short reply. 0.2. In the year 1988, what is the difference between the General Parity Index (GPI) in Botswana and General Parity Index (GPI) in Korea (Republic)?
Provide a succinct answer. 0.07. In the year 1988, what is the difference between the General Parity Index (GPI) of Botswana and General Parity Index (GPI) of Nigeria?
Give a very brief answer. 0.31. In the year 1988, what is the difference between the General Parity Index (GPI) in Korea (Republic) and General Parity Index (GPI) in Nigeria?
Make the answer very short. 0.25. In the year 1989, what is the difference between the General Parity Index (GPI) of Europe(developing only) and General Parity Index (GPI) of Botswana?
Provide a short and direct response. -0.11. In the year 1989, what is the difference between the General Parity Index (GPI) of Europe(developing only) and General Parity Index (GPI) of Korea (Republic)?
Keep it short and to the point. -0.05. In the year 1989, what is the difference between the General Parity Index (GPI) of Europe(developing only) and General Parity Index (GPI) of Nigeria?
Offer a very short reply. 0.11. In the year 1989, what is the difference between the General Parity Index (GPI) of Botswana and General Parity Index (GPI) of Korea (Republic)?
Provide a succinct answer. 0.06. In the year 1989, what is the difference between the General Parity Index (GPI) of Botswana and General Parity Index (GPI) of Nigeria?
Provide a short and direct response. 0.22. In the year 1989, what is the difference between the General Parity Index (GPI) in Korea (Republic) and General Parity Index (GPI) in Nigeria?
Offer a terse response. 0.16. In the year 1990, what is the difference between the General Parity Index (GPI) of Europe(developing only) and General Parity Index (GPI) of Botswana?
Your answer should be compact. -0.11. In the year 1990, what is the difference between the General Parity Index (GPI) of Europe(developing only) and General Parity Index (GPI) of Korea (Republic)?
Your answer should be compact. -0.05. In the year 1990, what is the difference between the General Parity Index (GPI) of Europe(developing only) and General Parity Index (GPI) of Nigeria?
Offer a very short reply. 0.17. In the year 1990, what is the difference between the General Parity Index (GPI) of Botswana and General Parity Index (GPI) of Korea (Republic)?
Keep it short and to the point. 0.06. In the year 1990, what is the difference between the General Parity Index (GPI) of Botswana and General Parity Index (GPI) of Nigeria?
Make the answer very short. 0.29. In the year 1990, what is the difference between the General Parity Index (GPI) of Korea (Republic) and General Parity Index (GPI) of Nigeria?
Provide a succinct answer. 0.22. In the year 1991, what is the difference between the General Parity Index (GPI) of Europe(developing only) and General Parity Index (GPI) of Botswana?
Provide a succinct answer. -0.1. In the year 1991, what is the difference between the General Parity Index (GPI) in Europe(developing only) and General Parity Index (GPI) in Korea (Republic)?
Your answer should be compact. -0.05. In the year 1991, what is the difference between the General Parity Index (GPI) in Europe(developing only) and General Parity Index (GPI) in Nigeria?
Your answer should be very brief. 0.15. In the year 1991, what is the difference between the General Parity Index (GPI) in Botswana and General Parity Index (GPI) in Korea (Republic)?
Keep it short and to the point. 0.05. In the year 1991, what is the difference between the General Parity Index (GPI) of Botswana and General Parity Index (GPI) of Nigeria?
Your response must be concise. 0.26. In the year 1991, what is the difference between the General Parity Index (GPI) in Korea (Republic) and General Parity Index (GPI) in Nigeria?
Provide a succinct answer. 0.2. In the year 1992, what is the difference between the General Parity Index (GPI) of Europe(developing only) and General Parity Index (GPI) of Botswana?
Your answer should be compact. -0.09. In the year 1992, what is the difference between the General Parity Index (GPI) in Europe(developing only) and General Parity Index (GPI) in Korea (Republic)?
Your answer should be compact. -0.05. In the year 1992, what is the difference between the General Parity Index (GPI) of Europe(developing only) and General Parity Index (GPI) of Nigeria?
Your response must be concise. 0.14. In the year 1992, what is the difference between the General Parity Index (GPI) in Botswana and General Parity Index (GPI) in Korea (Republic)?
Provide a succinct answer. 0.04. In the year 1992, what is the difference between the General Parity Index (GPI) in Botswana and General Parity Index (GPI) in Nigeria?
Keep it short and to the point. 0.23. In the year 1992, what is the difference between the General Parity Index (GPI) of Korea (Republic) and General Parity Index (GPI) of Nigeria?
Your answer should be compact. 0.19. What is the ratio of the General Parity Index (GPI) of Botswana in 1985 to that in 1986?
Offer a terse response. 1.02. What is the ratio of the General Parity Index (GPI) of Korea (Republic) in 1985 to that in 1986?
Your response must be concise. 1. What is the ratio of the General Parity Index (GPI) of Nigeria in 1985 to that in 1986?
Your response must be concise. 0.99. What is the ratio of the General Parity Index (GPI) in Europe(developing only) in 1985 to that in 1987?
Keep it short and to the point. 1. What is the ratio of the General Parity Index (GPI) in Botswana in 1985 to that in 1987?
Your answer should be compact. 1.03. What is the ratio of the General Parity Index (GPI) in Nigeria in 1985 to that in 1987?
Provide a succinct answer. 0.98. What is the ratio of the General Parity Index (GPI) of Europe(developing only) in 1985 to that in 1988?
Provide a succinct answer. 0.99. What is the ratio of the General Parity Index (GPI) of Botswana in 1985 to that in 1988?
Provide a short and direct response. 1.03. What is the ratio of the General Parity Index (GPI) of Nigeria in 1985 to that in 1988?
Provide a short and direct response. 1.07. What is the ratio of the General Parity Index (GPI) in Europe(developing only) in 1985 to that in 1989?
Ensure brevity in your answer.  0.99. What is the ratio of the General Parity Index (GPI) in Botswana in 1985 to that in 1989?
Keep it short and to the point. 1.04. What is the ratio of the General Parity Index (GPI) in Korea (Republic) in 1985 to that in 1989?
Keep it short and to the point. 1. What is the ratio of the General Parity Index (GPI) of Nigeria in 1985 to that in 1989?
Provide a succinct answer. 0.96. What is the ratio of the General Parity Index (GPI) of Botswana in 1985 to that in 1990?
Your answer should be very brief. 1.03. What is the ratio of the General Parity Index (GPI) in Nigeria in 1985 to that in 1990?
Ensure brevity in your answer.  1.03. What is the ratio of the General Parity Index (GPI) of Botswana in 1985 to that in 1991?
Make the answer very short. 1.04. What is the ratio of the General Parity Index (GPI) of Europe(developing only) in 1985 to that in 1992?
Offer a terse response. 0.99. What is the ratio of the General Parity Index (GPI) in Botswana in 1985 to that in 1992?
Keep it short and to the point. 1.05. What is the ratio of the General Parity Index (GPI) of Korea (Republic) in 1985 to that in 1992?
Provide a short and direct response. 1. What is the ratio of the General Parity Index (GPI) of Nigeria in 1985 to that in 1992?
Keep it short and to the point. 0.99. What is the ratio of the General Parity Index (GPI) of Botswana in 1986 to that in 1987?
Your answer should be very brief. 1. What is the ratio of the General Parity Index (GPI) in Nigeria in 1986 to that in 1987?
Give a very brief answer. 1. What is the ratio of the General Parity Index (GPI) of Korea (Republic) in 1986 to that in 1988?
Offer a very short reply. 1. What is the ratio of the General Parity Index (GPI) of Nigeria in 1986 to that in 1988?
Keep it short and to the point. 1.08. What is the ratio of the General Parity Index (GPI) of Botswana in 1986 to that in 1989?
Offer a very short reply. 1.01. What is the ratio of the General Parity Index (GPI) of Nigeria in 1986 to that in 1989?
Your answer should be compact. 0.97. What is the ratio of the General Parity Index (GPI) in Europe(developing only) in 1986 to that in 1990?
Your answer should be very brief. 1. What is the ratio of the General Parity Index (GPI) of Botswana in 1986 to that in 1990?
Your answer should be very brief. 1.01. What is the ratio of the General Parity Index (GPI) in Korea (Republic) in 1986 to that in 1990?
Offer a terse response. 1. What is the ratio of the General Parity Index (GPI) of Nigeria in 1986 to that in 1990?
Provide a short and direct response. 1.04. What is the ratio of the General Parity Index (GPI) in Europe(developing only) in 1986 to that in 1991?
Keep it short and to the point. 1. What is the ratio of the General Parity Index (GPI) in Botswana in 1986 to that in 1991?
Your answer should be very brief. 1.02. What is the ratio of the General Parity Index (GPI) of Korea (Republic) in 1986 to that in 1991?
Your answer should be compact. 1. What is the ratio of the General Parity Index (GPI) of Nigeria in 1986 to that in 1991?
Keep it short and to the point. 1.02. What is the ratio of the General Parity Index (GPI) in Europe(developing only) in 1986 to that in 1992?
Offer a terse response. 0.99. What is the ratio of the General Parity Index (GPI) of Botswana in 1986 to that in 1992?
Ensure brevity in your answer.  1.03. What is the ratio of the General Parity Index (GPI) of Nigeria in 1986 to that in 1992?
Offer a terse response. 1. What is the ratio of the General Parity Index (GPI) of Europe(developing only) in 1987 to that in 1988?
Give a very brief answer. 1. What is the ratio of the General Parity Index (GPI) in Botswana in 1987 to that in 1988?
Your response must be concise. 1. What is the ratio of the General Parity Index (GPI) in Nigeria in 1987 to that in 1988?
Provide a short and direct response. 1.08. What is the ratio of the General Parity Index (GPI) of Europe(developing only) in 1987 to that in 1989?
Give a very brief answer. 1. What is the ratio of the General Parity Index (GPI) in Botswana in 1987 to that in 1989?
Offer a terse response. 1.01. What is the ratio of the General Parity Index (GPI) in Korea (Republic) in 1987 to that in 1989?
Give a very brief answer. 1. What is the ratio of the General Parity Index (GPI) of Nigeria in 1987 to that in 1989?
Ensure brevity in your answer.  0.97. What is the ratio of the General Parity Index (GPI) in Europe(developing only) in 1987 to that in 1990?
Offer a terse response. 1. What is the ratio of the General Parity Index (GPI) in Botswana in 1987 to that in 1990?
Ensure brevity in your answer.  1. What is the ratio of the General Parity Index (GPI) of Nigeria in 1987 to that in 1990?
Make the answer very short. 1.05. What is the ratio of the General Parity Index (GPI) of Botswana in 1987 to that in 1991?
Give a very brief answer. 1.01. What is the ratio of the General Parity Index (GPI) of Nigeria in 1987 to that in 1991?
Give a very brief answer. 1.02. What is the ratio of the General Parity Index (GPI) in Europe(developing only) in 1987 to that in 1992?
Your answer should be very brief. 0.99. What is the ratio of the General Parity Index (GPI) of Botswana in 1987 to that in 1992?
Give a very brief answer. 1.02. What is the ratio of the General Parity Index (GPI) in Nigeria in 1987 to that in 1992?
Provide a succinct answer. 1.01. What is the ratio of the General Parity Index (GPI) of Botswana in 1988 to that in 1989?
Keep it short and to the point. 1.01. What is the ratio of the General Parity Index (GPI) in Nigeria in 1988 to that in 1989?
Give a very brief answer. 0.9. What is the ratio of the General Parity Index (GPI) in Europe(developing only) in 1988 to that in 1990?
Your response must be concise. 1. What is the ratio of the General Parity Index (GPI) of Korea (Republic) in 1988 to that in 1990?
Offer a very short reply. 1. What is the ratio of the General Parity Index (GPI) of Nigeria in 1988 to that in 1990?
Ensure brevity in your answer.  0.97. What is the ratio of the General Parity Index (GPI) in Nigeria in 1988 to that in 1991?
Make the answer very short. 0.94. What is the ratio of the General Parity Index (GPI) of Europe(developing only) in 1988 to that in 1992?
Your answer should be compact. 1. What is the ratio of the General Parity Index (GPI) of Botswana in 1988 to that in 1992?
Provide a short and direct response. 1.02. What is the ratio of the General Parity Index (GPI) in Korea (Republic) in 1988 to that in 1992?
Offer a terse response. 1. What is the ratio of the General Parity Index (GPI) of Nigeria in 1988 to that in 1992?
Ensure brevity in your answer.  0.93. What is the ratio of the General Parity Index (GPI) of Korea (Republic) in 1989 to that in 1990?
Give a very brief answer. 1. What is the ratio of the General Parity Index (GPI) of Nigeria in 1989 to that in 1990?
Provide a succinct answer. 1.08. What is the ratio of the General Parity Index (GPI) of Korea (Republic) in 1989 to that in 1991?
Provide a succinct answer. 1. What is the ratio of the General Parity Index (GPI) in Nigeria in 1989 to that in 1991?
Offer a very short reply. 1.05. What is the ratio of the General Parity Index (GPI) of Europe(developing only) in 1989 to that in 1992?
Offer a very short reply. 1. What is the ratio of the General Parity Index (GPI) in Botswana in 1989 to that in 1992?
Your answer should be very brief. 1.01. What is the ratio of the General Parity Index (GPI) of Korea (Republic) in 1989 to that in 1992?
Your answer should be compact. 1. What is the ratio of the General Parity Index (GPI) in Nigeria in 1989 to that in 1992?
Provide a succinct answer. 1.03. What is the ratio of the General Parity Index (GPI) of Europe(developing only) in 1990 to that in 1991?
Your response must be concise. 1. What is the ratio of the General Parity Index (GPI) in Botswana in 1990 to that in 1991?
Provide a short and direct response. 1.01. What is the ratio of the General Parity Index (GPI) in Korea (Republic) in 1990 to that in 1991?
Your answer should be compact. 1. What is the ratio of the General Parity Index (GPI) of Nigeria in 1990 to that in 1991?
Offer a terse response. 0.98. What is the ratio of the General Parity Index (GPI) of Botswana in 1990 to that in 1992?
Ensure brevity in your answer.  1.02. What is the ratio of the General Parity Index (GPI) in Korea (Republic) in 1990 to that in 1992?
Your response must be concise. 1. What is the ratio of the General Parity Index (GPI) in Nigeria in 1990 to that in 1992?
Provide a short and direct response. 0.96. What is the ratio of the General Parity Index (GPI) in Europe(developing only) in 1991 to that in 1992?
Offer a very short reply. 1. What is the ratio of the General Parity Index (GPI) of Botswana in 1991 to that in 1992?
Your answer should be very brief. 1.01. What is the difference between the highest and the second highest General Parity Index (GPI) of Europe(developing only)?
Offer a very short reply. 0. What is the difference between the highest and the second highest General Parity Index (GPI) of Botswana?
Offer a very short reply. 0.03. What is the difference between the highest and the second highest General Parity Index (GPI) in Korea (Republic)?
Give a very brief answer. 0. What is the difference between the highest and the second highest General Parity Index (GPI) of Nigeria?
Your answer should be compact. 0.02. What is the difference between the highest and the lowest General Parity Index (GPI) of Europe(developing only)?
Your answer should be compact. 0.01. What is the difference between the highest and the lowest General Parity Index (GPI) in Botswana?
Make the answer very short. 0.05. What is the difference between the highest and the lowest General Parity Index (GPI) in Korea (Republic)?
Offer a terse response. 0.01. What is the difference between the highest and the lowest General Parity Index (GPI) of Nigeria?
Your answer should be very brief. 0.09. 